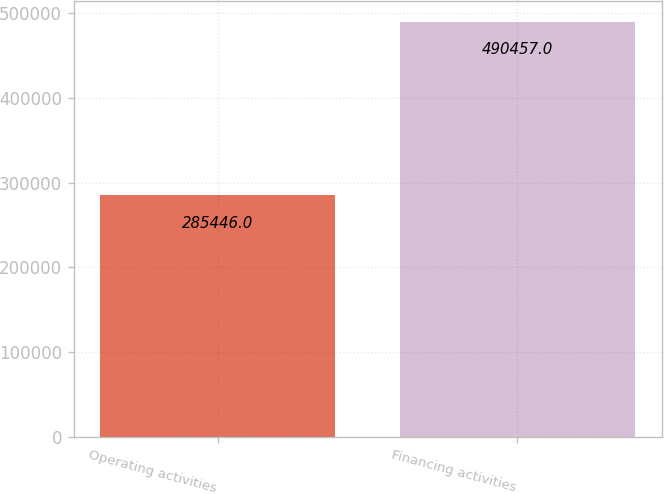Convert chart to OTSL. <chart><loc_0><loc_0><loc_500><loc_500><bar_chart><fcel>Operating activities<fcel>Financing activities<nl><fcel>285446<fcel>490457<nl></chart> 